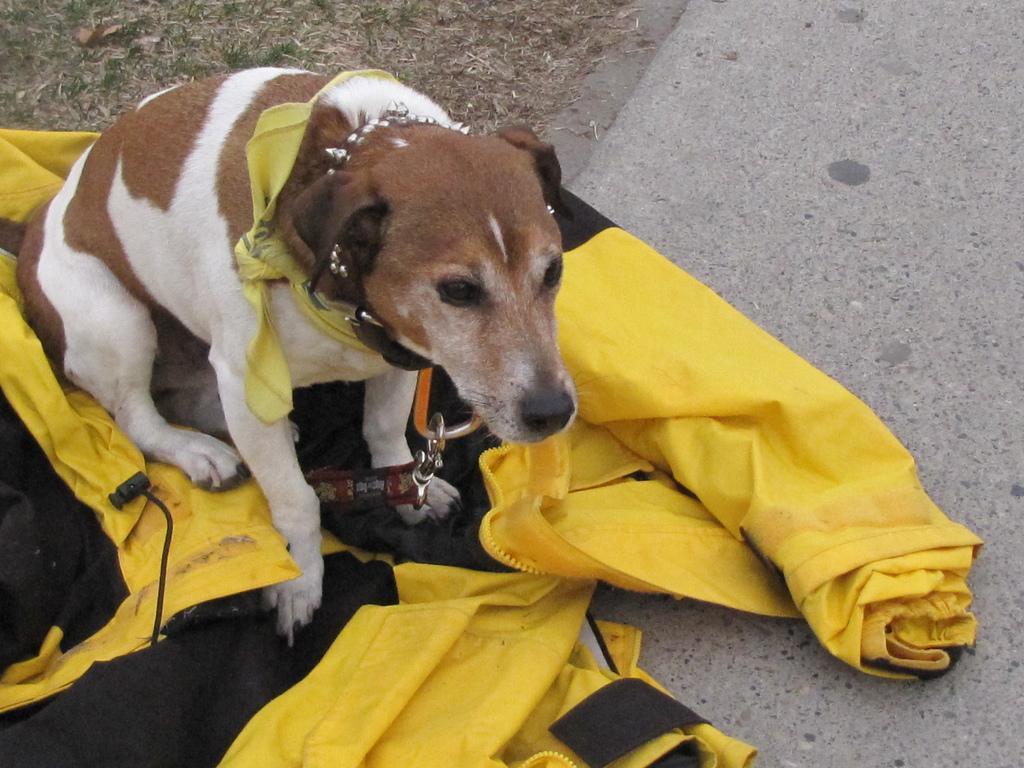In one or two sentences, can you explain what this image depicts? In this picture there is a dog on the left side of the image, on a jacket. 